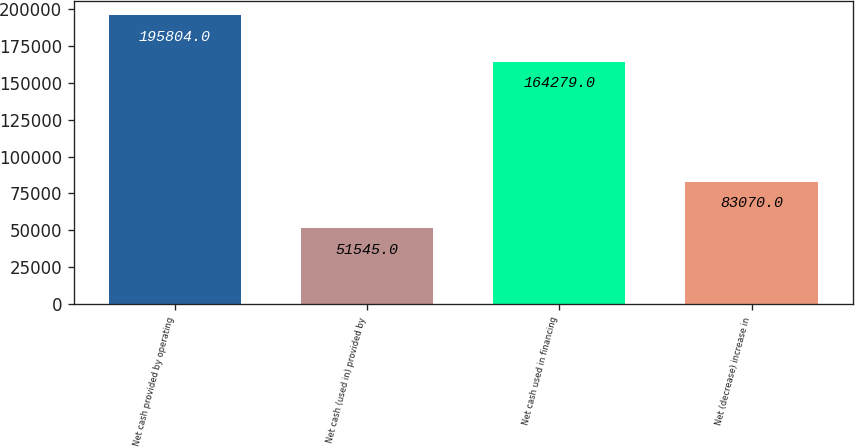<chart> <loc_0><loc_0><loc_500><loc_500><bar_chart><fcel>Net cash provided by operating<fcel>Net cash (used in) provided by<fcel>Net cash used in financing<fcel>Net (decrease) increase in<nl><fcel>195804<fcel>51545<fcel>164279<fcel>83070<nl></chart> 